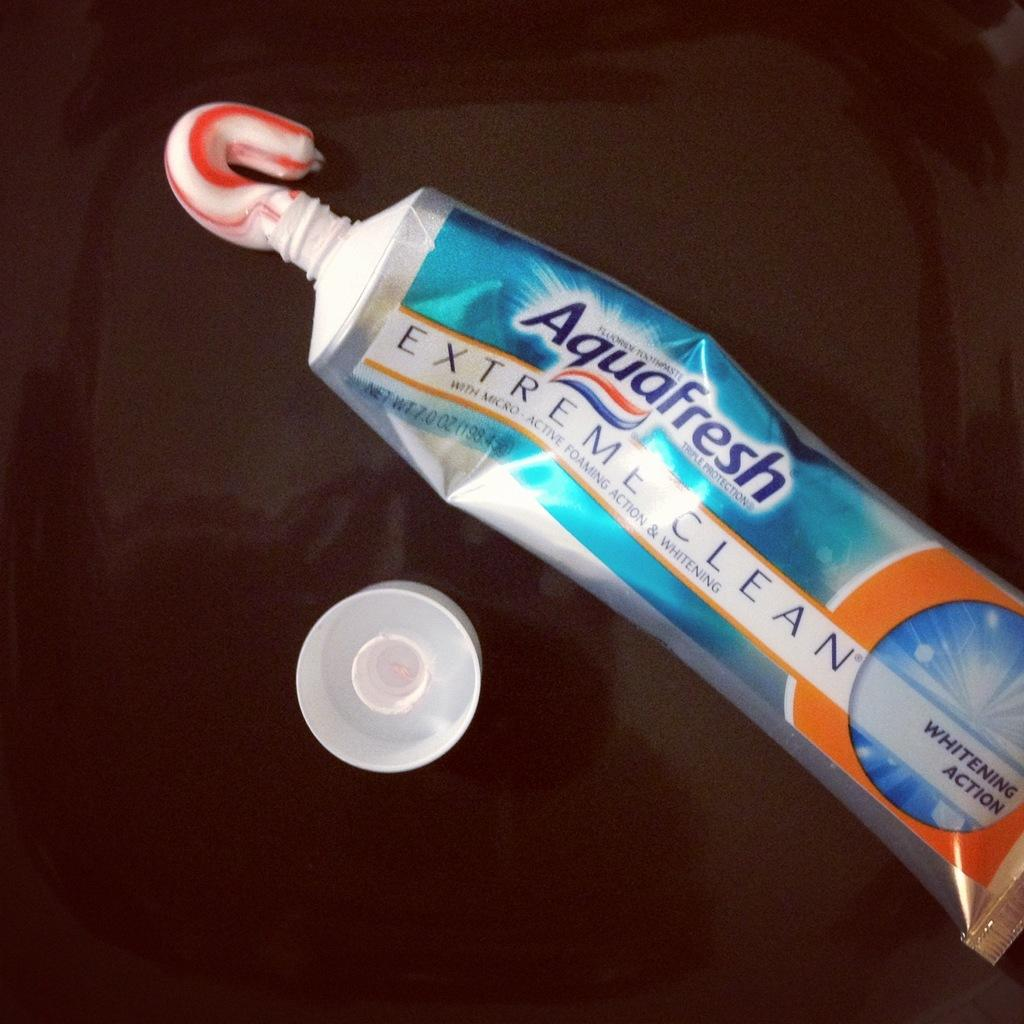<image>
Summarize the visual content of the image. A tube of Aquafresh extreme clean toothpaste with toothpaste squeezed out at the opening. 